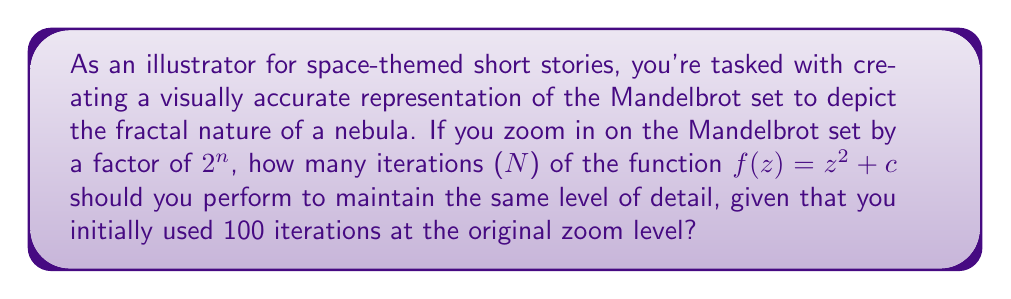Could you help me with this problem? To solve this problem, we need to understand the relationship between the zoom factor and the number of iterations required in the Mandelbrot set calculation.

1) The Mandelbrot set is defined by the function $f(z) = z^2 + c$, where $z$ and $c$ are complex numbers.

2) The number of iterations required to maintain the same level of detail is proportional to the square root of the zoom factor.

3) In this case, the zoom factor is $2^n$.

4) Let's call the new number of iterations $N$. The relationship can be expressed as:

   $$\frac{N}{100} = \sqrt{2^n}$$

5) Simplifying the right side:
   
   $$\frac{N}{100} = 2^{\frac{n}{2}}$$

6) Solving for $N$:

   $$N = 100 \cdot 2^{\frac{n}{2}}$$

This formula gives us the number of iterations needed for any zoom level $2^n$ to maintain the same level of detail as 100 iterations at the original zoom level.
Answer: $N = 100 \cdot 2^{\frac{n}{2}}$ 